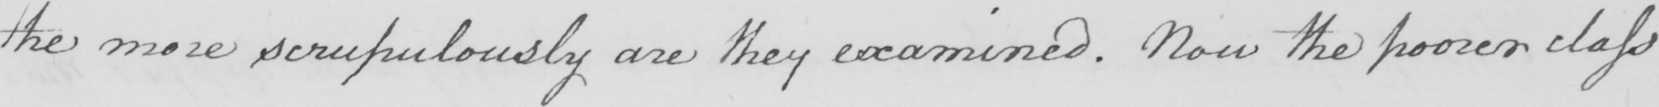Please provide the text content of this handwritten line. the more scrupulously are they examined . Now the poorer class 